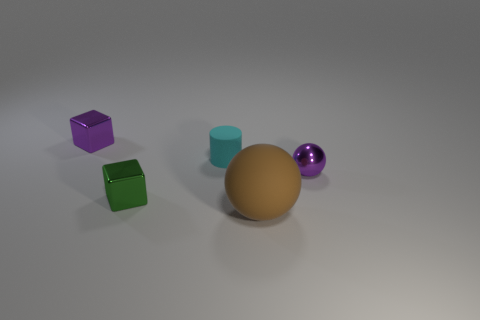How big is the metallic object that is to the right of the tiny green metallic block that is in front of the small shiny object right of the brown rubber ball?
Make the answer very short. Small. How many other objects are there of the same shape as the tiny cyan matte object?
Give a very brief answer. 0. Does the metallic block that is behind the tiny cyan cylinder have the same color as the ball that is to the left of the tiny sphere?
Provide a succinct answer. No. What is the color of the ball that is the same size as the green cube?
Offer a very short reply. Purple. Are there any big matte things of the same color as the tiny cylinder?
Offer a very short reply. No. Does the metallic object behind the purple sphere have the same size as the big matte ball?
Keep it short and to the point. No. Are there an equal number of brown balls that are behind the purple cube and shiny objects?
Keep it short and to the point. No. What number of things are things right of the cyan rubber thing or large green things?
Offer a terse response. 2. What is the shape of the shiny thing that is left of the tiny metallic ball and in front of the cyan rubber object?
Your answer should be compact. Cube. What number of things are shiny things in front of the small purple metallic ball or objects behind the matte sphere?
Offer a very short reply. 4. 